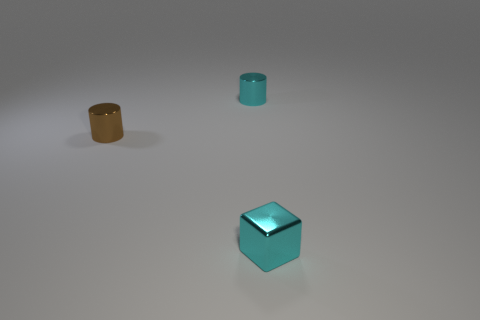How does the lighting in the image affect the appearance of the objects? The lighting creates a soft shadow on the side of the objects opposite the light source, indicating that the illumination is directional. This lighting adds depth to the objects and enhances the perception of their three-dimensional shapes. 